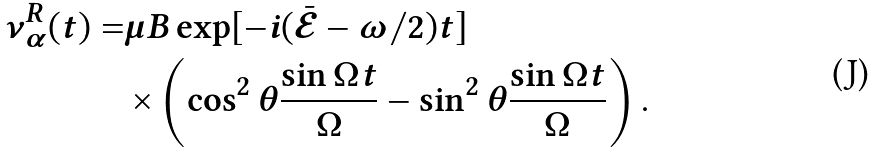<formula> <loc_0><loc_0><loc_500><loc_500>\nu _ { \alpha } ^ { R } ( t ) = & \mu B \exp [ - i ( \bar { \mathcal { E } } - \omega / 2 ) t ] \\ & \times \left ( \cos ^ { 2 } \theta \frac { \sin \Omega _ { } t } { \Omega _ { } } - \sin ^ { 2 } \theta \frac { \sin \Omega _ { } t } { \Omega _ { } } \right ) .</formula> 